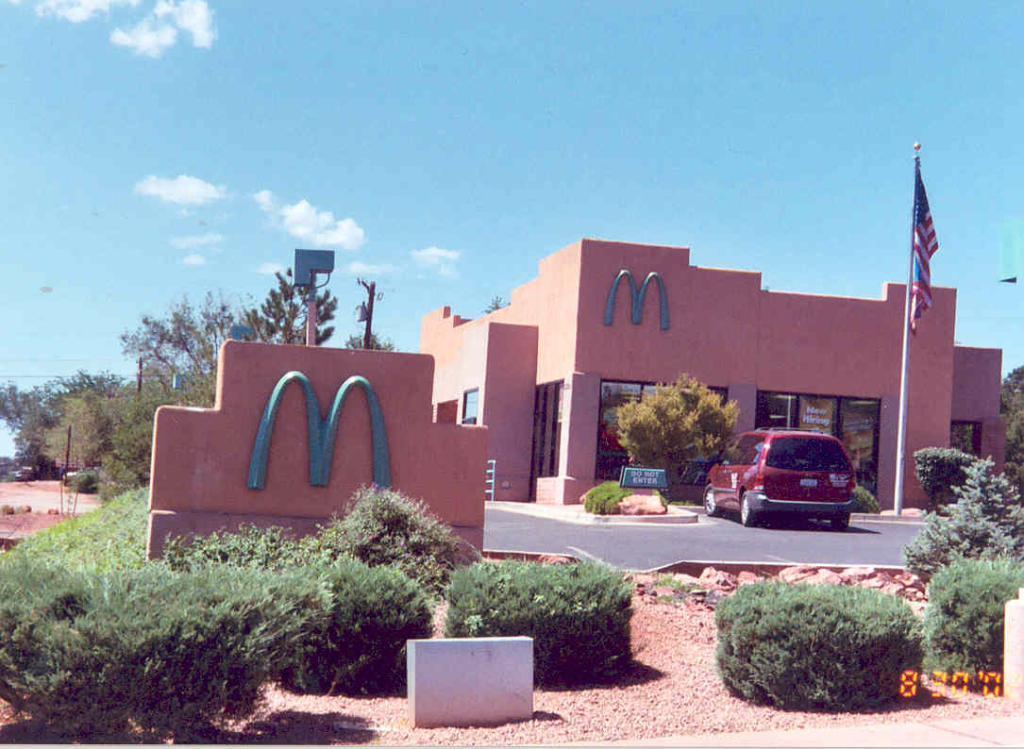Please provide a concise description of this image. In this image there are plants and there is a logo on a wall, in the background there is a car on a pavement and there is a flag, building, trees and the sky. 